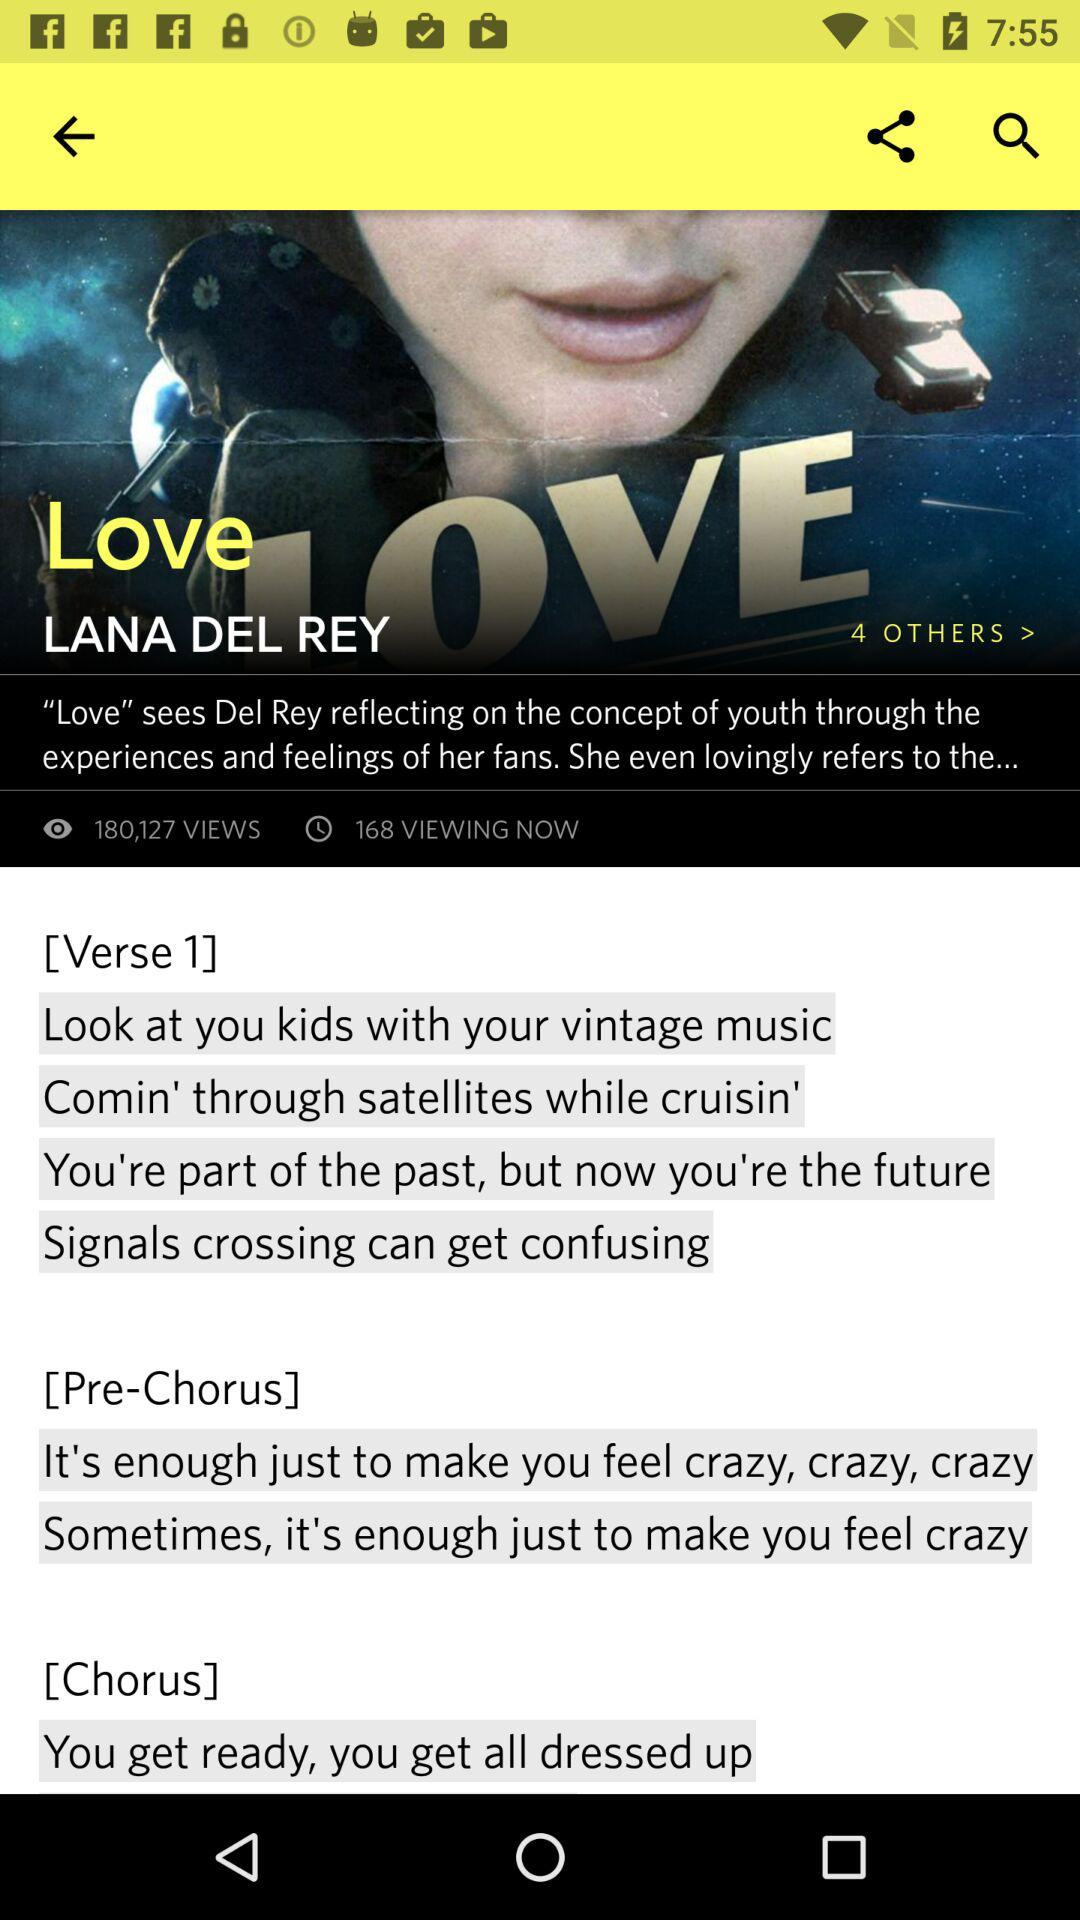What is the name of the singer? The name of the singer is Lana Del Rey. 